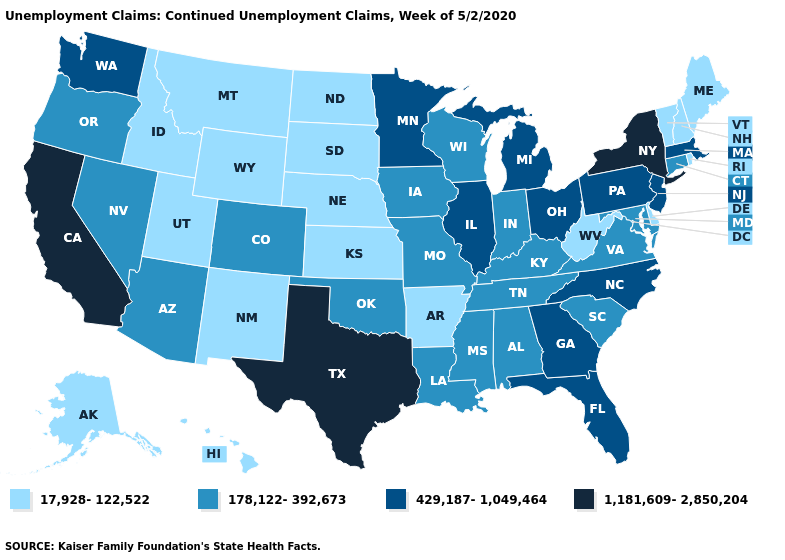What is the highest value in the MidWest ?
Be succinct. 429,187-1,049,464. Among the states that border Tennessee , does Arkansas have the highest value?
Concise answer only. No. Does Pennsylvania have a lower value than New York?
Be succinct. Yes. Which states have the lowest value in the USA?
Be succinct. Alaska, Arkansas, Delaware, Hawaii, Idaho, Kansas, Maine, Montana, Nebraska, New Hampshire, New Mexico, North Dakota, Rhode Island, South Dakota, Utah, Vermont, West Virginia, Wyoming. What is the value of Vermont?
Write a very short answer. 17,928-122,522. Which states have the lowest value in the USA?
Quick response, please. Alaska, Arkansas, Delaware, Hawaii, Idaho, Kansas, Maine, Montana, Nebraska, New Hampshire, New Mexico, North Dakota, Rhode Island, South Dakota, Utah, Vermont, West Virginia, Wyoming. Which states have the highest value in the USA?
Write a very short answer. California, New York, Texas. Does Washington have the lowest value in the USA?
Answer briefly. No. Does Maryland have the lowest value in the USA?
Give a very brief answer. No. Name the states that have a value in the range 1,181,609-2,850,204?
Concise answer only. California, New York, Texas. What is the highest value in the Northeast ?
Keep it brief. 1,181,609-2,850,204. Which states have the lowest value in the USA?
Keep it brief. Alaska, Arkansas, Delaware, Hawaii, Idaho, Kansas, Maine, Montana, Nebraska, New Hampshire, New Mexico, North Dakota, Rhode Island, South Dakota, Utah, Vermont, West Virginia, Wyoming. Name the states that have a value in the range 178,122-392,673?
Quick response, please. Alabama, Arizona, Colorado, Connecticut, Indiana, Iowa, Kentucky, Louisiana, Maryland, Mississippi, Missouri, Nevada, Oklahoma, Oregon, South Carolina, Tennessee, Virginia, Wisconsin. What is the value of Nebraska?
Keep it brief. 17,928-122,522. What is the value of Nevada?
Answer briefly. 178,122-392,673. 